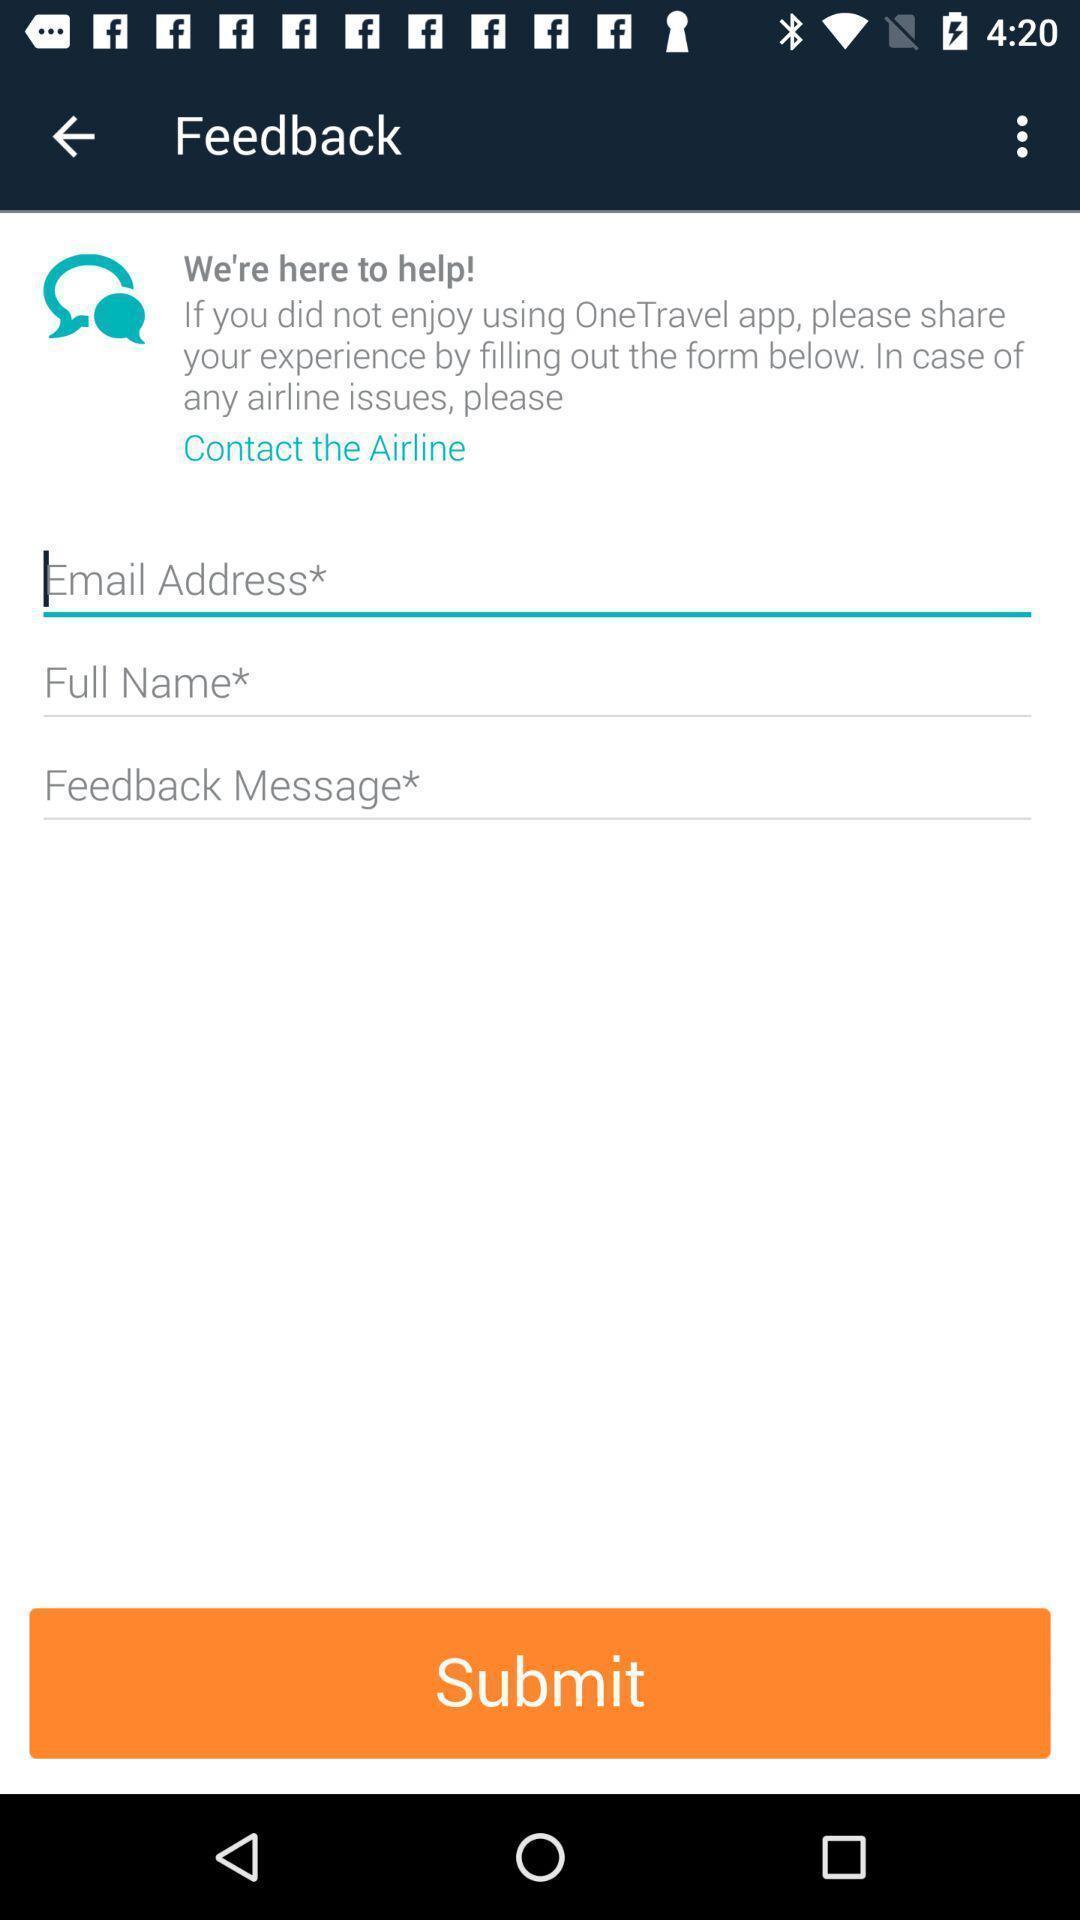Give me a narrative description of this picture. Page shows to enter details for feedback submission. 